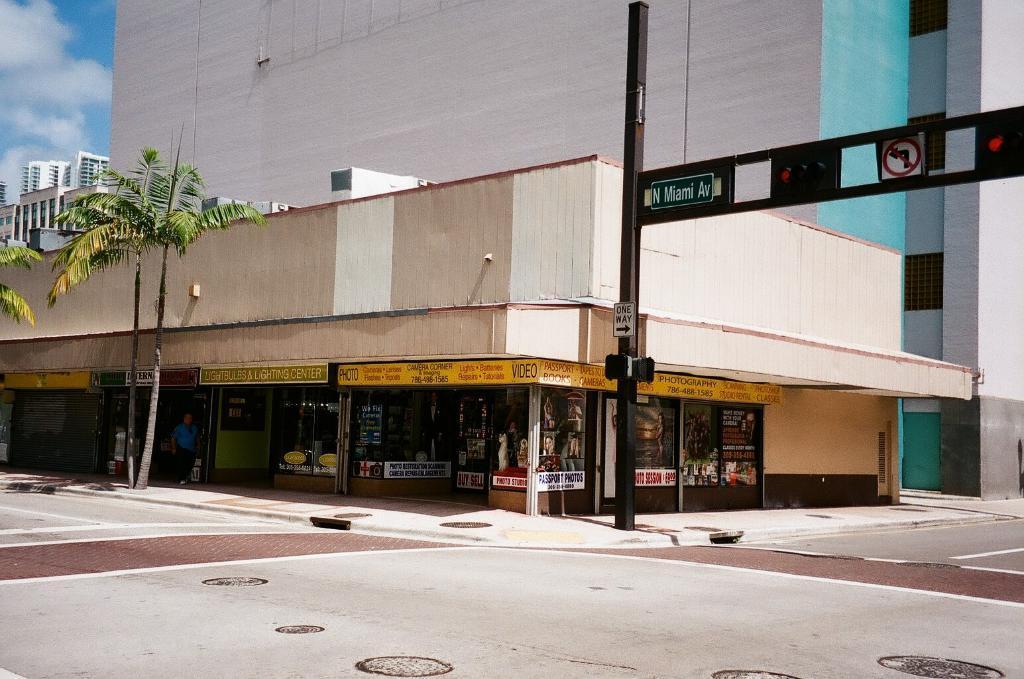Can you describe this image briefly? Beside the road there are different stores and in front of the stores there are three tall trees, on the right side there is a pole and to the pole there are caution boards and traffic signal lights, above the stores there is a huge building and in the background there is a sky. 